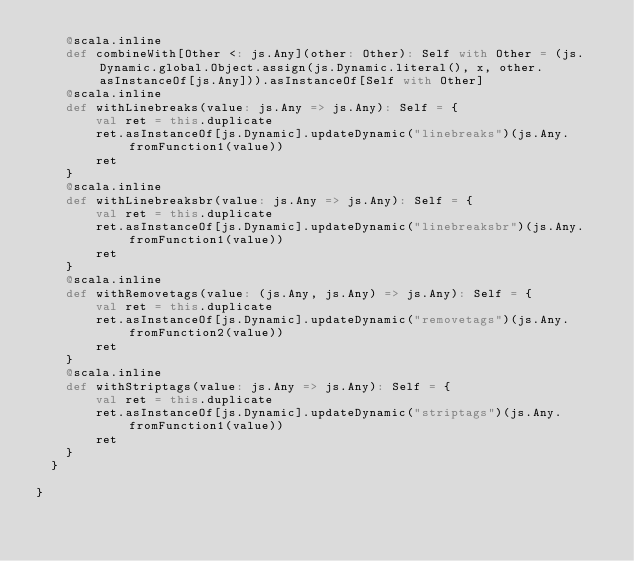Convert code to text. <code><loc_0><loc_0><loc_500><loc_500><_Scala_>    @scala.inline
    def combineWith[Other <: js.Any](other: Other): Self with Other = (js.Dynamic.global.Object.assign(js.Dynamic.literal(), x, other.asInstanceOf[js.Any])).asInstanceOf[Self with Other]
    @scala.inline
    def withLinebreaks(value: js.Any => js.Any): Self = {
        val ret = this.duplicate
        ret.asInstanceOf[js.Dynamic].updateDynamic("linebreaks")(js.Any.fromFunction1(value))
        ret
    }
    @scala.inline
    def withLinebreaksbr(value: js.Any => js.Any): Self = {
        val ret = this.duplicate
        ret.asInstanceOf[js.Dynamic].updateDynamic("linebreaksbr")(js.Any.fromFunction1(value))
        ret
    }
    @scala.inline
    def withRemovetags(value: (js.Any, js.Any) => js.Any): Self = {
        val ret = this.duplicate
        ret.asInstanceOf[js.Dynamic].updateDynamic("removetags")(js.Any.fromFunction2(value))
        ret
    }
    @scala.inline
    def withStriptags(value: js.Any => js.Any): Self = {
        val ret = this.duplicate
        ret.asInstanceOf[js.Dynamic].updateDynamic("striptags")(js.Any.fromFunction1(value))
        ret
    }
  }
  
}

</code> 